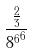<formula> <loc_0><loc_0><loc_500><loc_500>\frac { \frac { 2 } { 3 } } { { 8 ^ { 6 } } ^ { 6 } }</formula> 